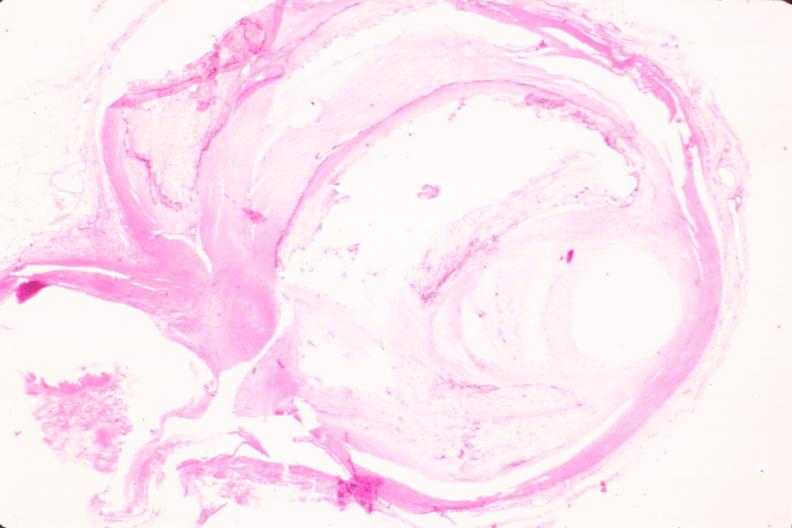does this image show coronary artery atherosclerosis?
Answer the question using a single word or phrase. Yes 